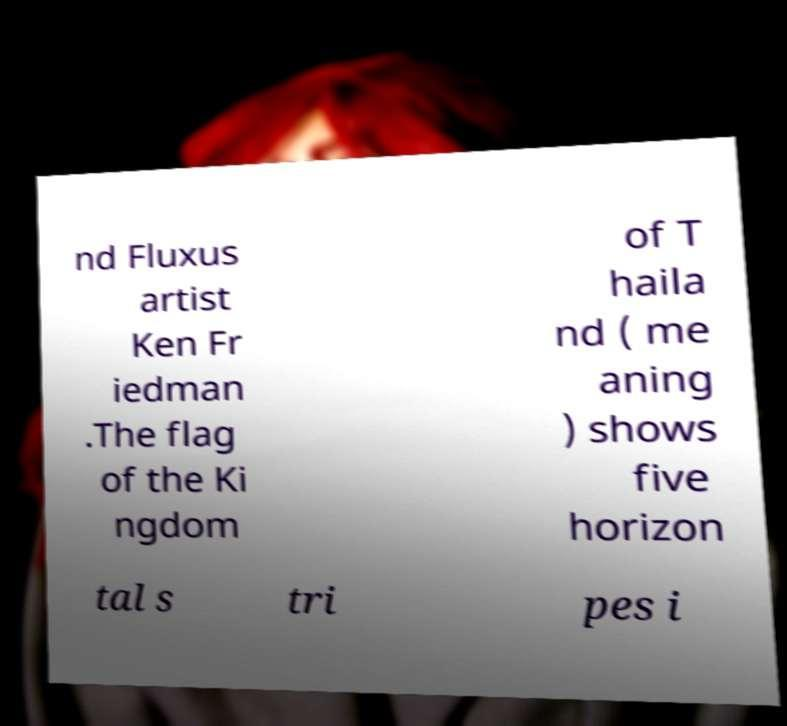I need the written content from this picture converted into text. Can you do that? nd Fluxus artist Ken Fr iedman .The flag of the Ki ngdom of T haila nd ( me aning ) shows five horizon tal s tri pes i 